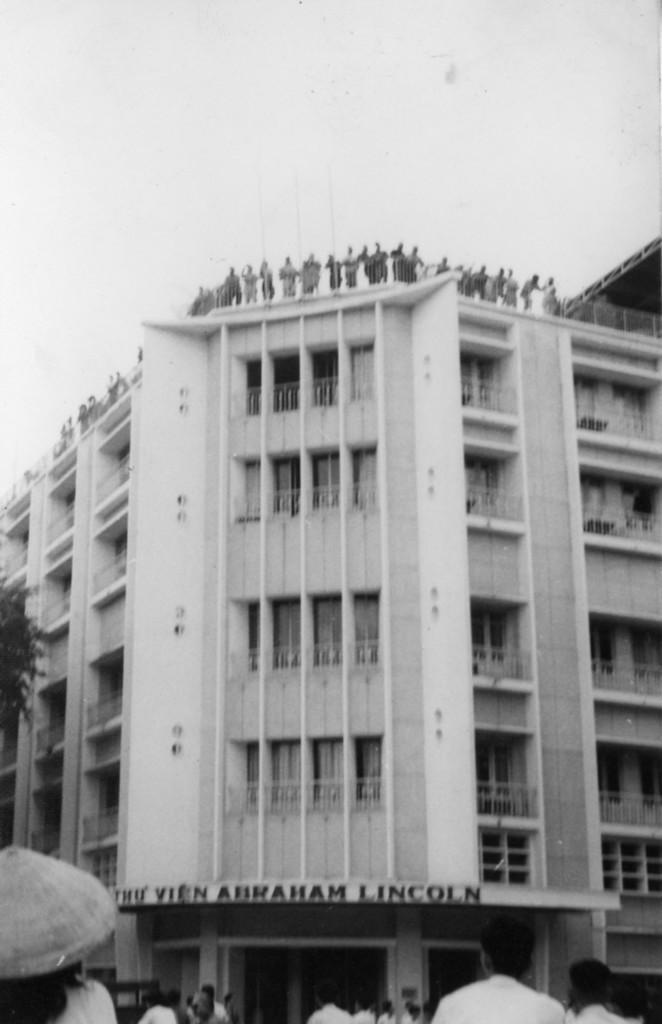Can you describe this image briefly? In the picture we can see a building which is white in color with a window and some people standing on the top of the building near the railing and the name of the building is the vein Abraham Lincoln and besides the building we can see some people are standing. 